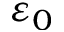Convert formula to latex. <formula><loc_0><loc_0><loc_500><loc_500>\varepsilon _ { 0 }</formula> 